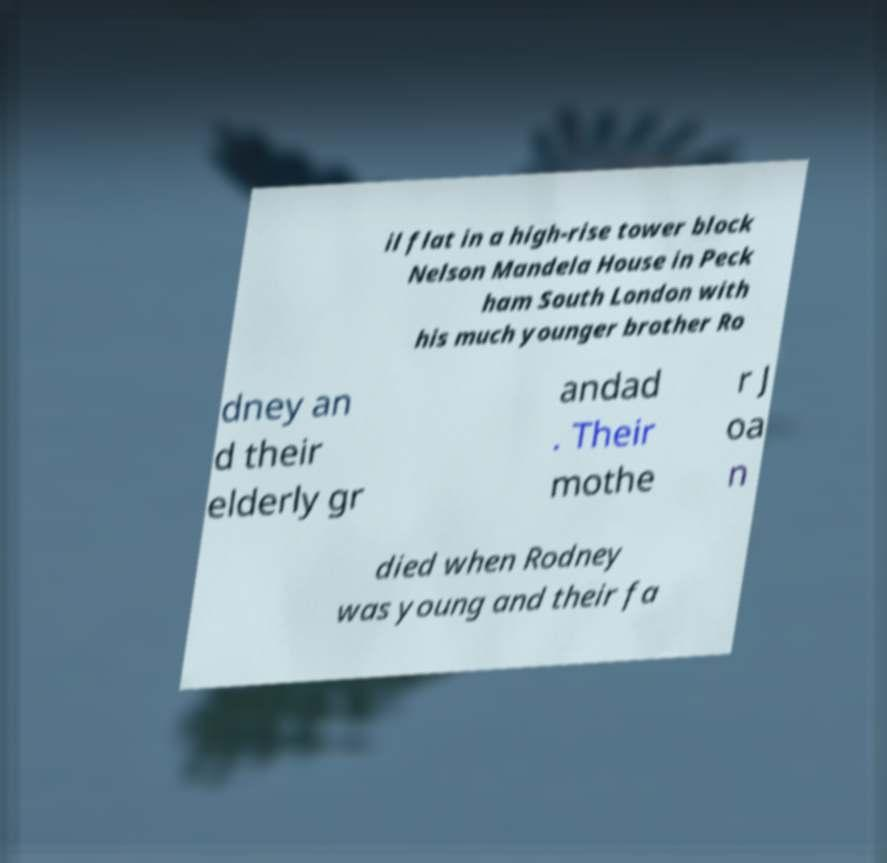Could you assist in decoding the text presented in this image and type it out clearly? il flat in a high-rise tower block Nelson Mandela House in Peck ham South London with his much younger brother Ro dney an d their elderly gr andad . Their mothe r J oa n died when Rodney was young and their fa 